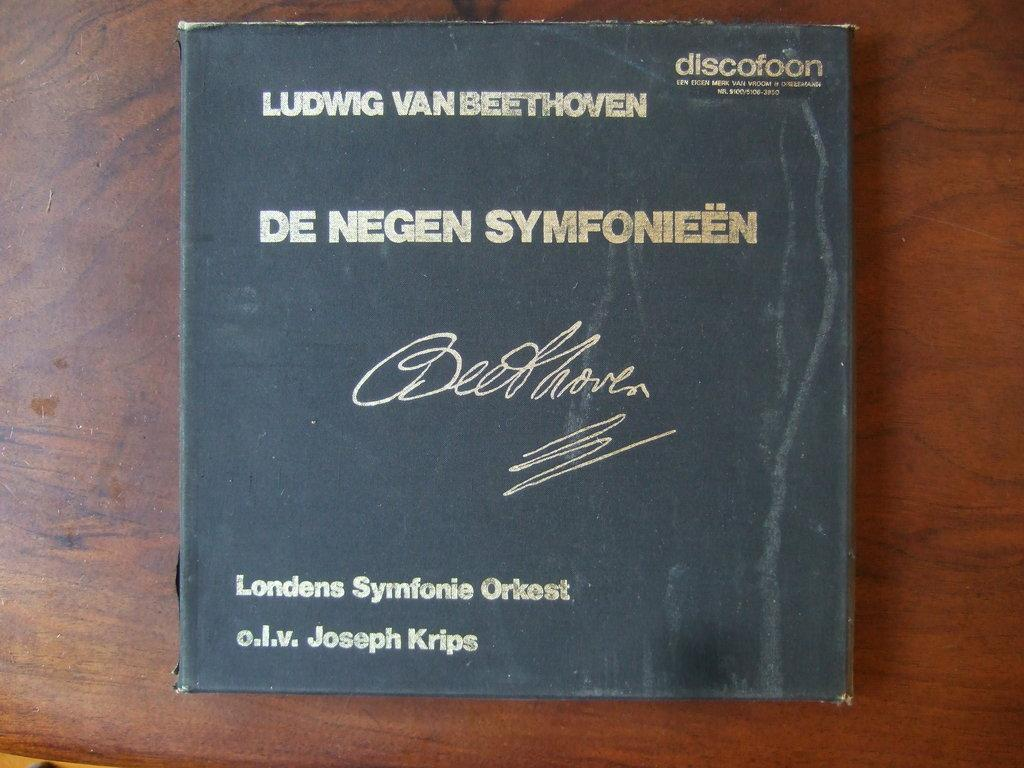<image>
Relay a brief, clear account of the picture shown. A well preserved, signed, Beethoven book lays on the wooden table 